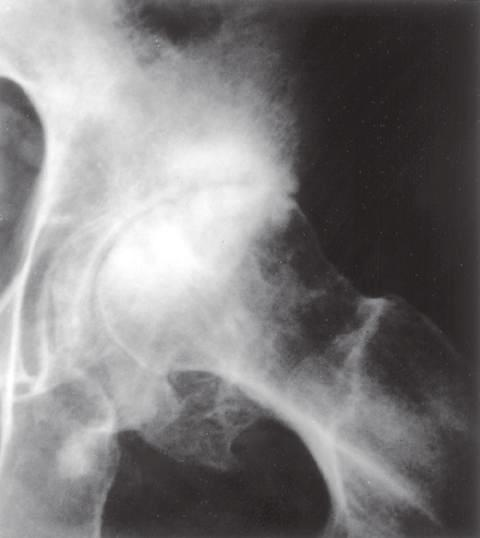s the embolus subchondral sclerosis with scattered oval radiolucent cysts and peripheral osteophyte lipping (arrows)?
Answer the question using a single word or phrase. No 